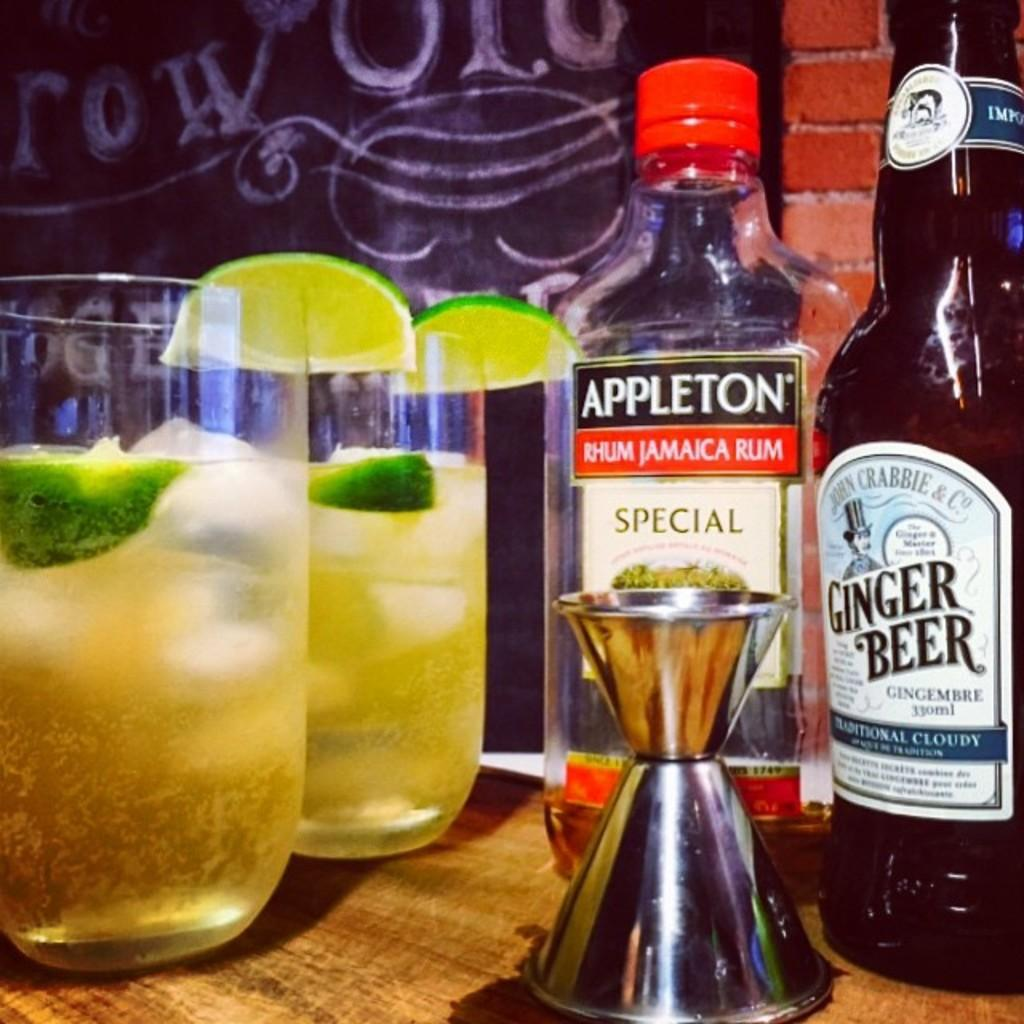<image>
Create a compact narrative representing the image presented. Drinks sitting on a table with a bottle marked Appleton Rhum Jamaica Rum 